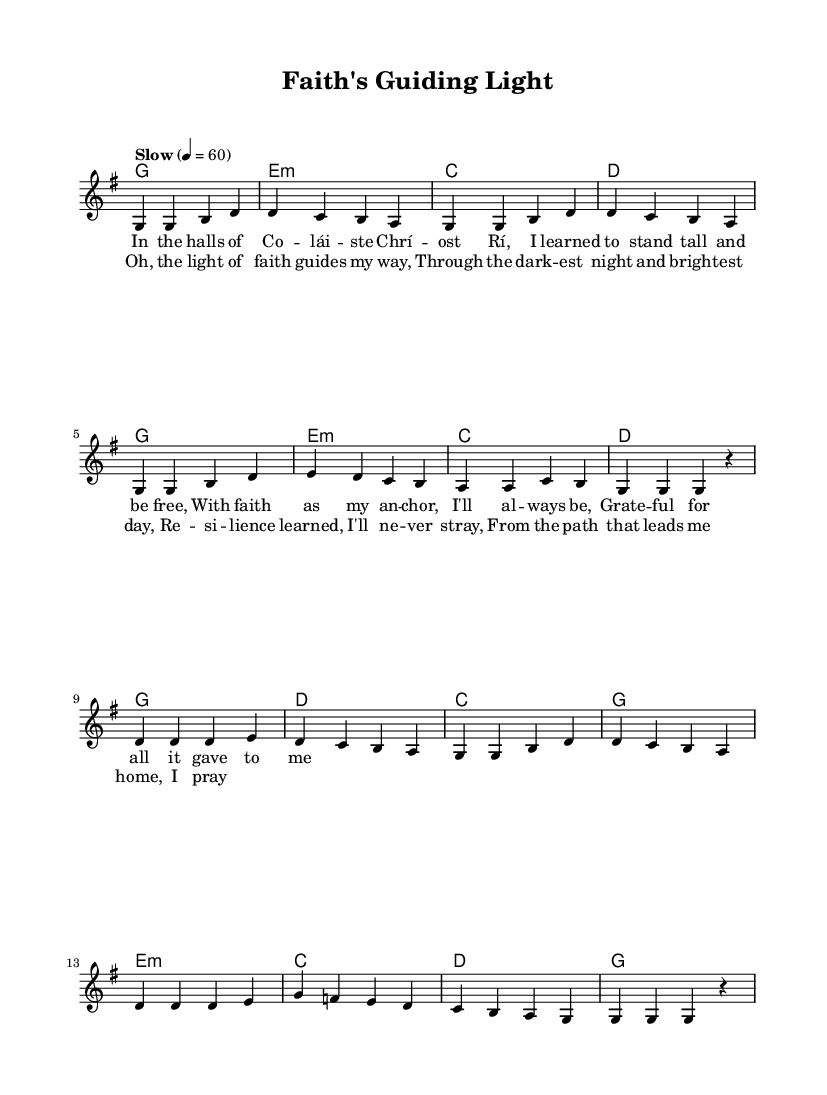What is the key signature of this music? The key signature shown at the beginning of the sheet music indicates G major, which has one sharp. This can be identified by looking at the key signature symbol right after the clef sign.
Answer: G major What is the time signature of this music? The time signature is located next to the key signature at the start of the score. Here, it shows 4/4, meaning there are four beats in each measure and the quarter note gets one beat.
Answer: 4/4 What is the tempo indication of this music? The tempo marking is found at the beginning of the piece, indicating how fast the music should be played. In this case, it specifies "Slow" with a quarter note equals sixty beats per minute, which sets a calm pace.
Answer: Slow What are the main themes present in the lyrics? The lyrics reflect themes of faith and resilience, emphasizing gratitude and guidance through difficult times. By examining both the verse and chorus lyrics, one can see these recurring ideas.
Answer: Faith and resilience How many measures are in the chorus? By counting the measures in the notation of the chorus section, we find that there are eight measures in total, indicated by the notation and the gaps between the phrases.
Answer: Eight What chords are used in the verses? The chords listed under the verse section correspond to the harmonic progression of the melody in that part of the song. They are G, E minor, C, and D, repeated throughout the verse.
Answer: G, E minor, C, D What is the structural form of this piece? Analyzing the layout of the music, we can see that it follows a typical song structure commonly used in soul ballads, with verses followed by a chorus. This alternation is a defining characteristic of many popular songs.
Answer: Verse-Chorus structure 